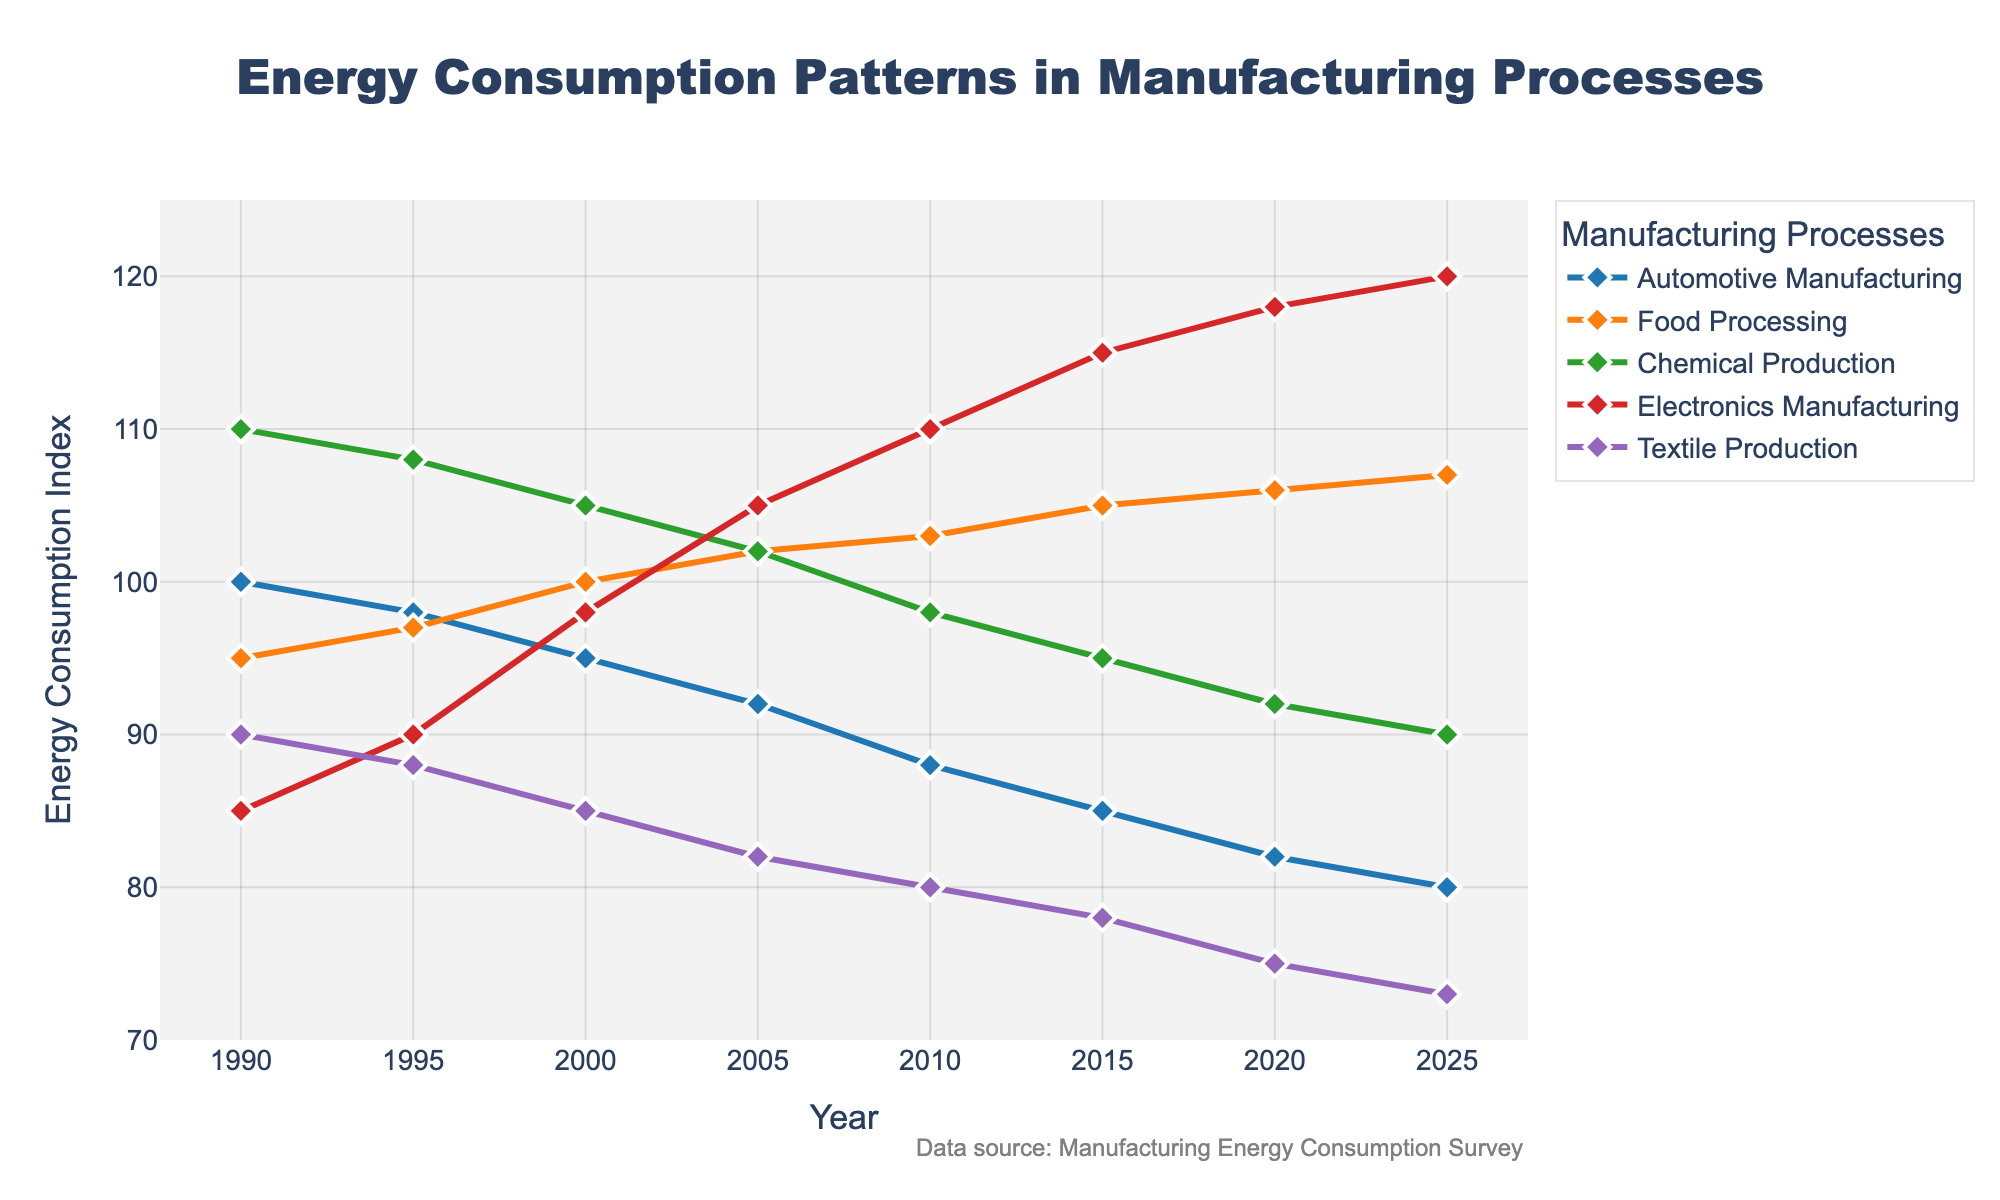What was the energy consumption index for Automotive Manufacturing in 2000? The line for Automotive Manufacturing intersects the value 95 on the y-axis for the year 2000 on the x-axis.
Answer: 95 Which manufacturing process had the highest energy consumption index in 2015? Locate the markers for 2015 and compare the heights of the lines at this point. Electronics Manufacturing has the highest value.
Answer: Electronics Manufacturing Between 1990 and 2020, which manufacturing process showed the most consistent decrease in energy consumption? Compare the energy consumption trends for each process. Automotive Manufacturing shows a consistent decline without any increases over the years.
Answer: Automotive Manufacturing What is the difference in energy consumption index between Electronics Manufacturing and Textile Production in 2020? Subtract the energy consumption index of Textile Production from that of Electronics Manufacturing in 2020. 118 (Electronics Manufacturing) - 75 (Textile Production) = 43.
Answer: 43 For which manufacturing process does the energy consumption index increase continuously from 1990 to 2025? Examine all lines and identify the one that rises continuously from start to end. The line for Electronics Manufacturing increases continuously over this period.
Answer: Electronics Manufacturing What is the average energy consumption index for Food Processing over the years shown? Sum the energy consumption values for Food Processing (95 + 97 + 100 + 102 + 103 + 105 + 106 + 107) and divide by the number of years (8). The sum is 815, and the average is 815 / 8 = 101.875.
Answer: 101.875 Which process had an energy consumption index equal to 85 in the year 1990? Look at the lines and markers for the year 1990. The Energy Consumption Index of 85 is observed for Electronics Manufacturing.
Answer: Electronics Manufacturing Has the energy consumption index for Chemical Production increased or decreased between 1990 and 2010? Compare the values in 1990 (110) and 2010 (98). Since 110 > 98, it has decreased.
Answer: Decreased What is the sum of energy consumption indices for Textile Production in the years 1990 and 2025? Add the values for Textile Production in 1990 (90) and 2025 (73). 90 + 73 = 163.
Answer: 163 In which year is the energy consumption index for Automotive Manufacturing equal to the energy consumption index for Textile Production? Compare the values year by year. In 2000, both Automotive Manufacturing and Textile Production have an index value (95).
Answer: 2000 